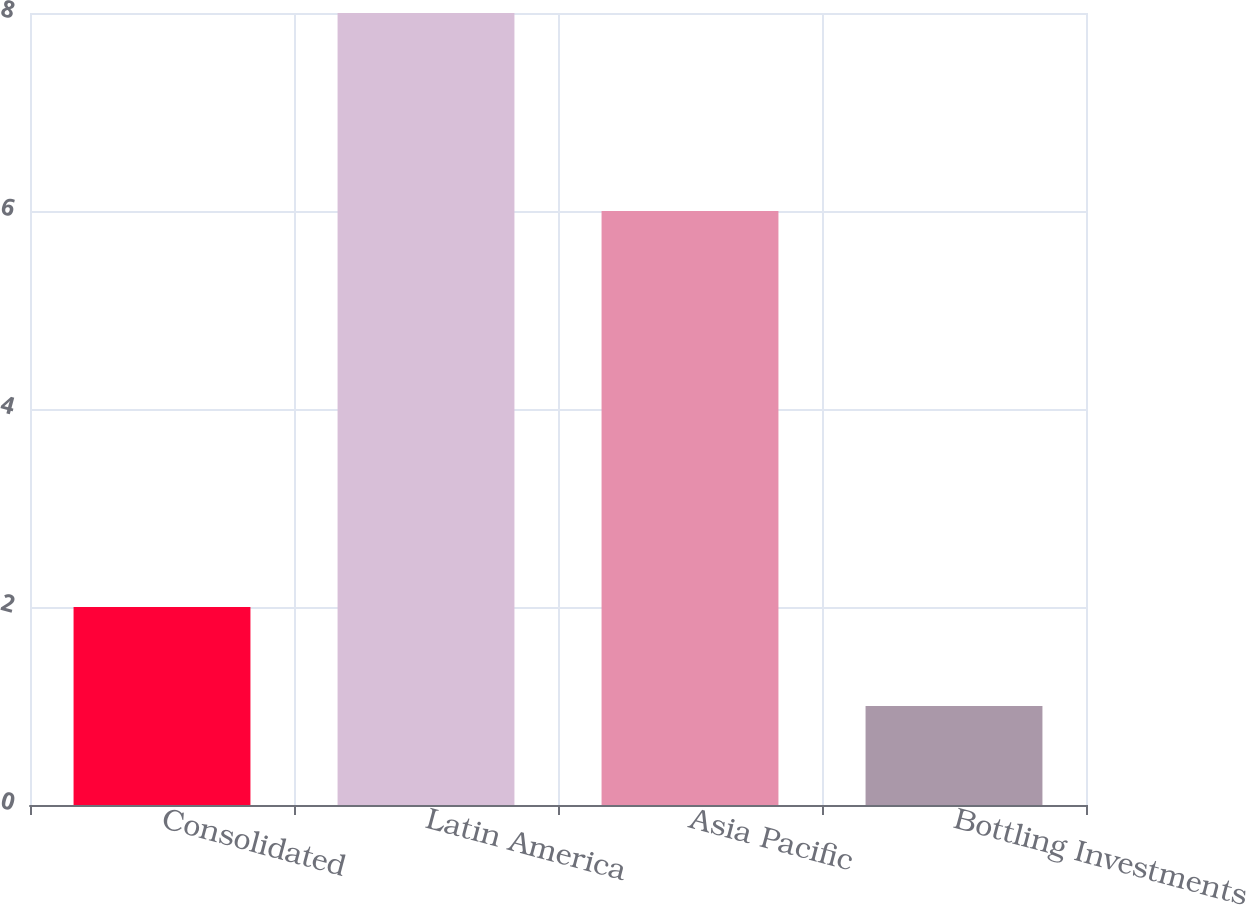Convert chart. <chart><loc_0><loc_0><loc_500><loc_500><bar_chart><fcel>Consolidated<fcel>Latin America<fcel>Asia Pacific<fcel>Bottling Investments<nl><fcel>2<fcel>8<fcel>6<fcel>1<nl></chart> 